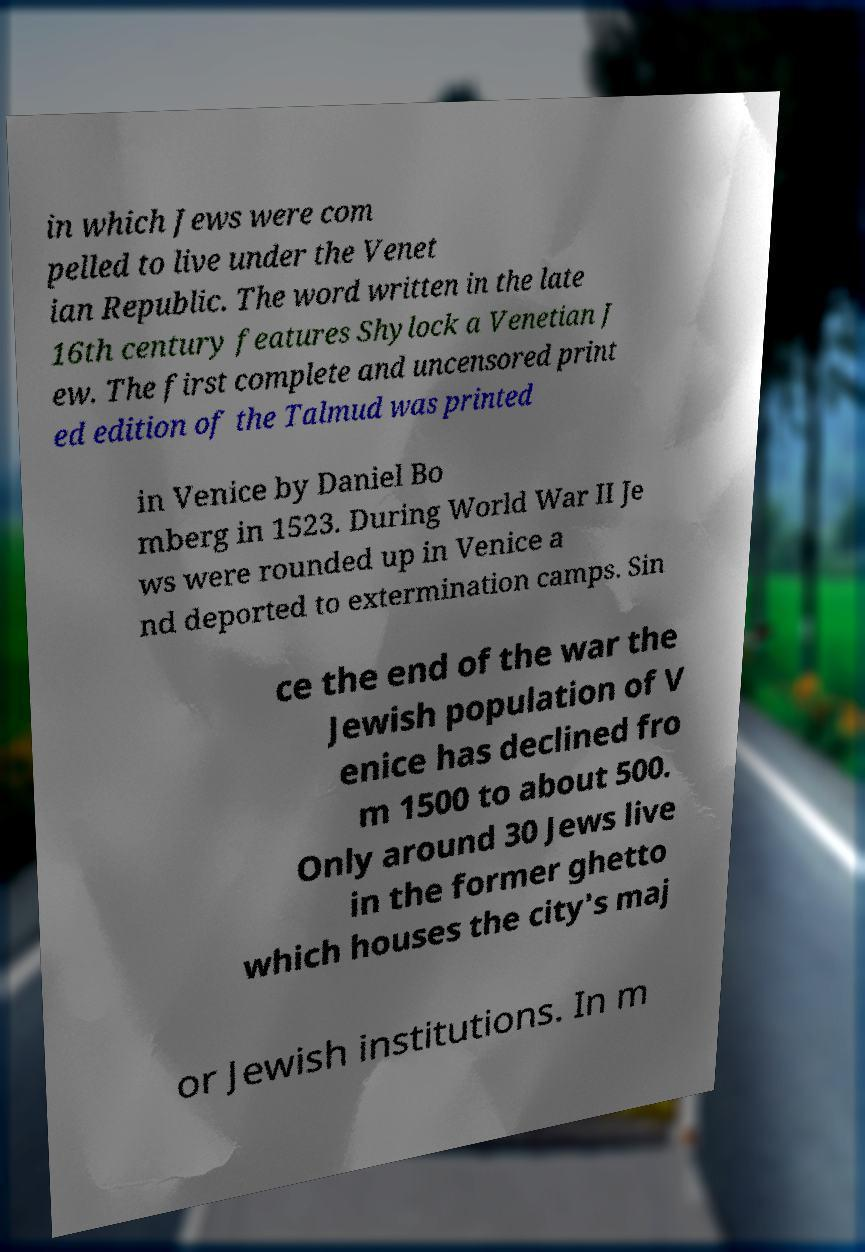Can you read and provide the text displayed in the image?This photo seems to have some interesting text. Can you extract and type it out for me? in which Jews were com pelled to live under the Venet ian Republic. The word written in the late 16th century features Shylock a Venetian J ew. The first complete and uncensored print ed edition of the Talmud was printed in Venice by Daniel Bo mberg in 1523. During World War II Je ws were rounded up in Venice a nd deported to extermination camps. Sin ce the end of the war the Jewish population of V enice has declined fro m 1500 to about 500. Only around 30 Jews live in the former ghetto which houses the city's maj or Jewish institutions. In m 